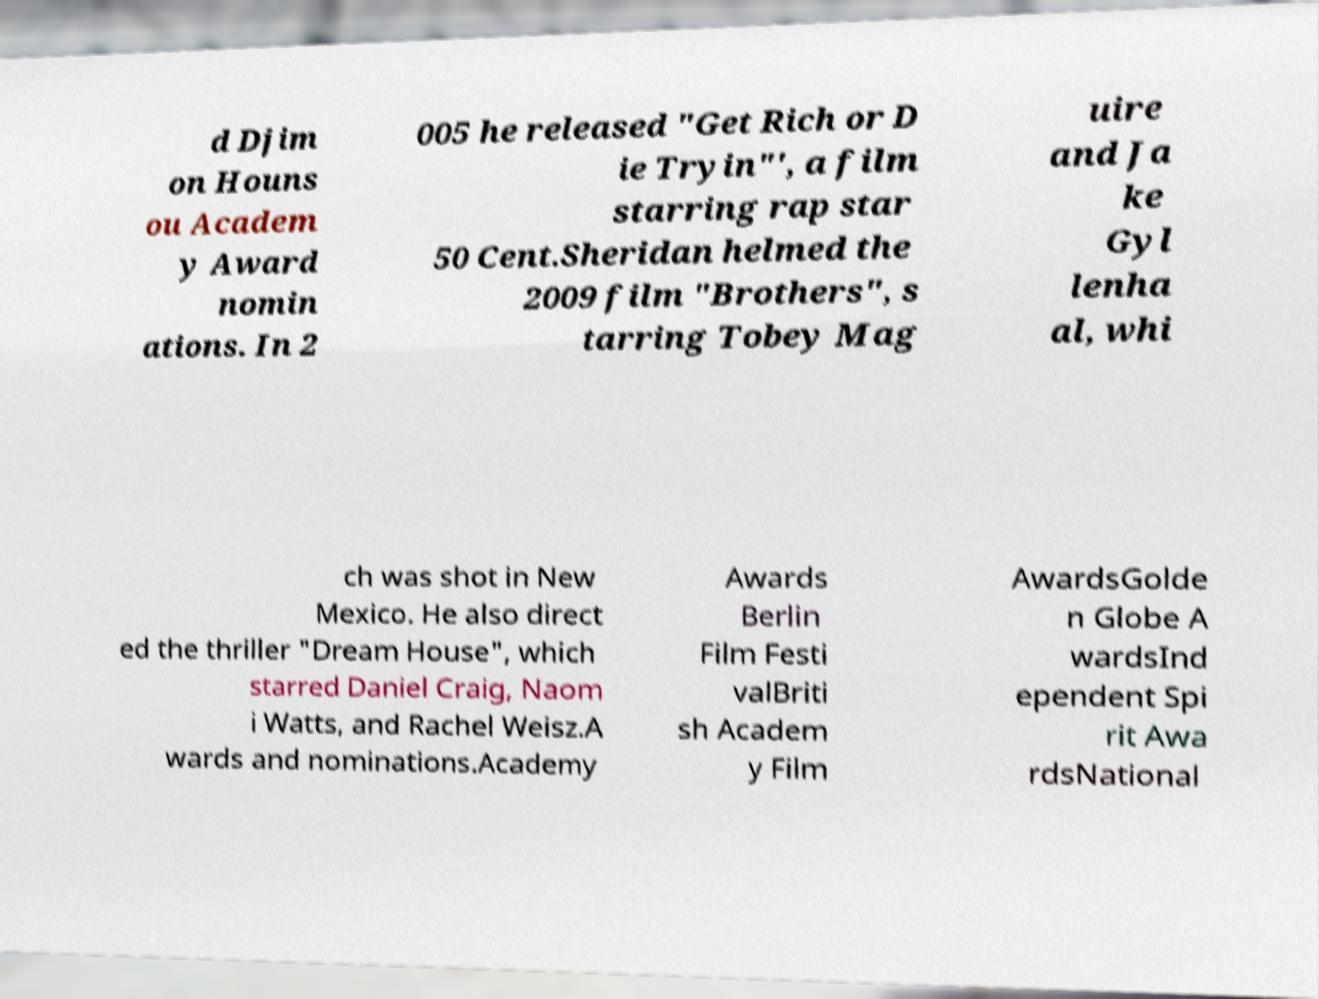Could you assist in decoding the text presented in this image and type it out clearly? d Djim on Houns ou Academ y Award nomin ations. In 2 005 he released "Get Rich or D ie Tryin"', a film starring rap star 50 Cent.Sheridan helmed the 2009 film "Brothers", s tarring Tobey Mag uire and Ja ke Gyl lenha al, whi ch was shot in New Mexico. He also direct ed the thriller "Dream House", which starred Daniel Craig, Naom i Watts, and Rachel Weisz.A wards and nominations.Academy Awards Berlin Film Festi valBriti sh Academ y Film AwardsGolde n Globe A wardsInd ependent Spi rit Awa rdsNational 